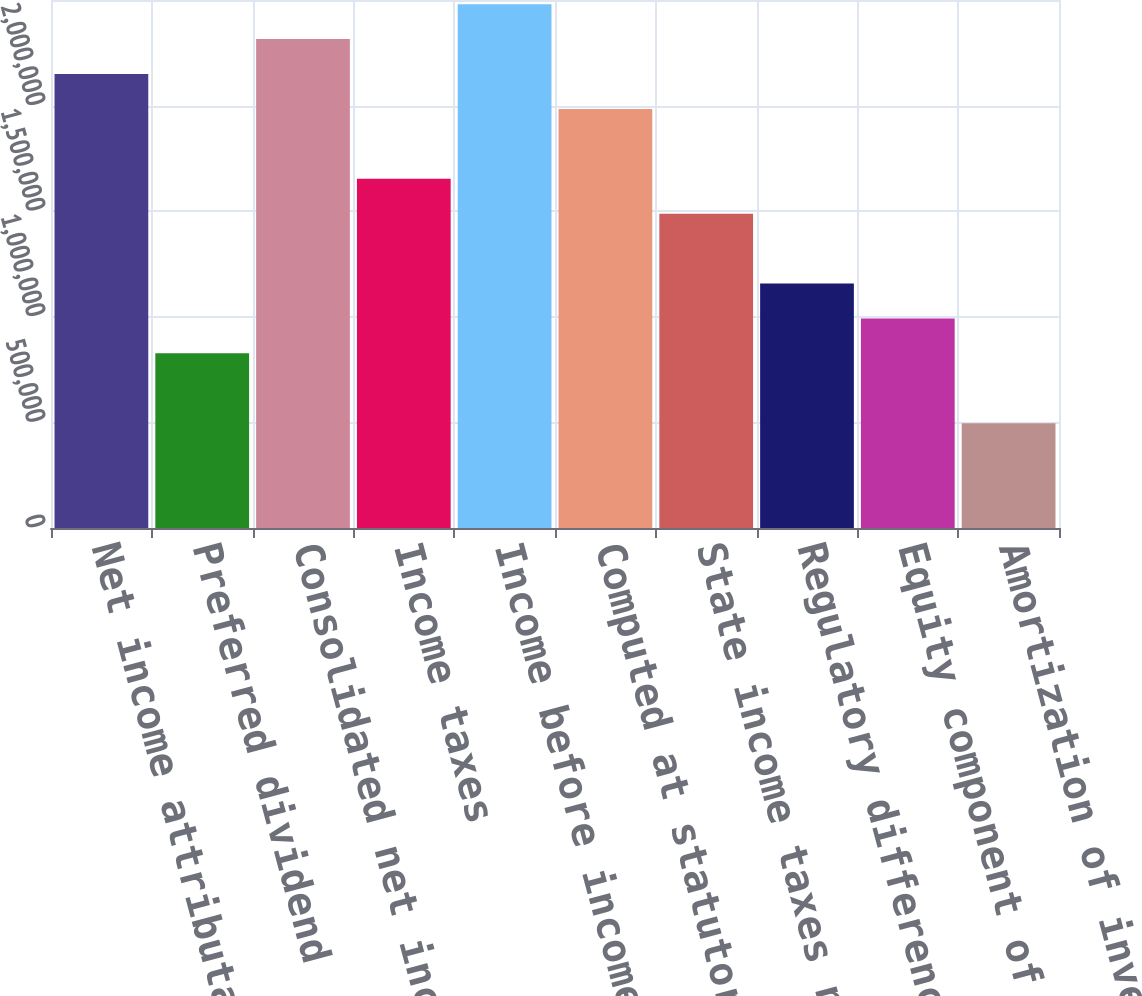<chart> <loc_0><loc_0><loc_500><loc_500><bar_chart><fcel>Net income attributable to<fcel>Preferred dividend<fcel>Consolidated net income<fcel>Income taxes<fcel>Income before income taxes<fcel>Computed at statutory rate<fcel>State income taxes net of<fcel>Regulatory differences -<fcel>Equity component of AFUDC<fcel>Amortization of investment tax<nl><fcel>2.14972e+06<fcel>826826<fcel>2.31508e+06<fcel>1.65364e+06<fcel>2.48044e+06<fcel>1.98436e+06<fcel>1.48827e+06<fcel>1.15755e+06<fcel>992188<fcel>496103<nl></chart> 